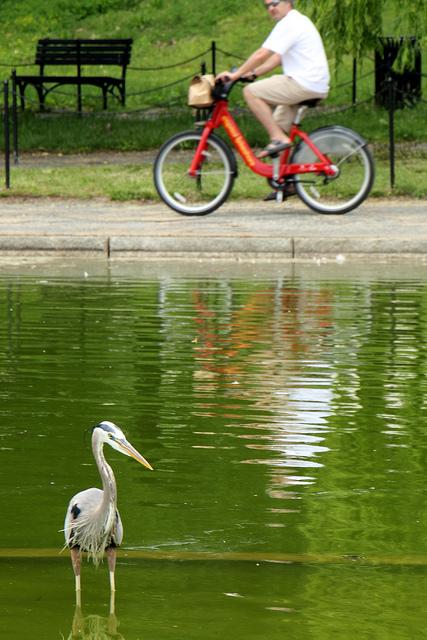At What location is the biker riding by the bird?

Choices:
A) chicken hut
B) city street
C) market
D) park park 